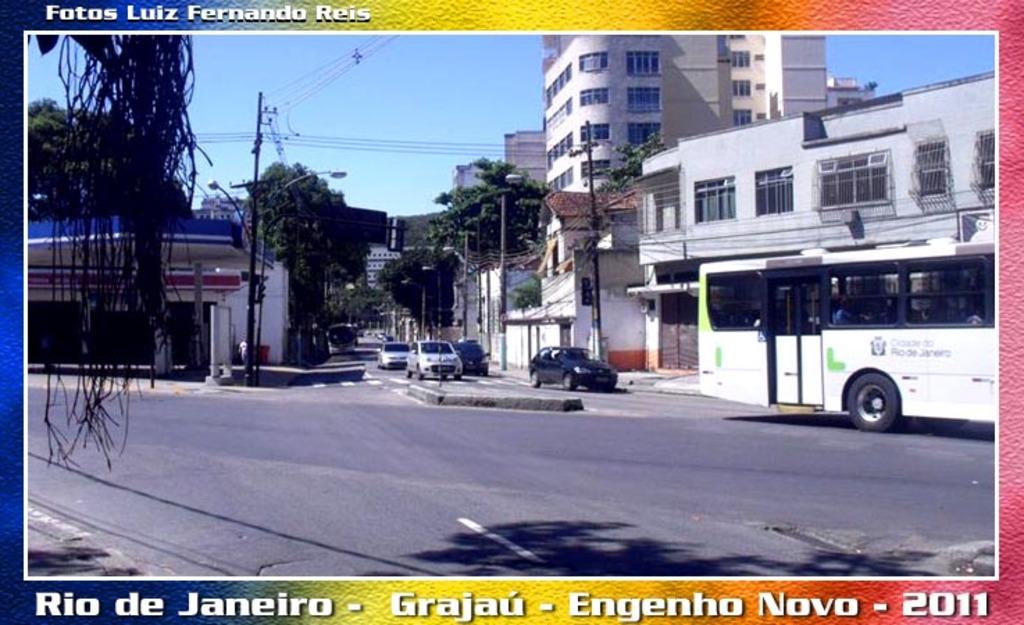What town is pictured here?
Offer a very short reply. Rio de janeiro. 